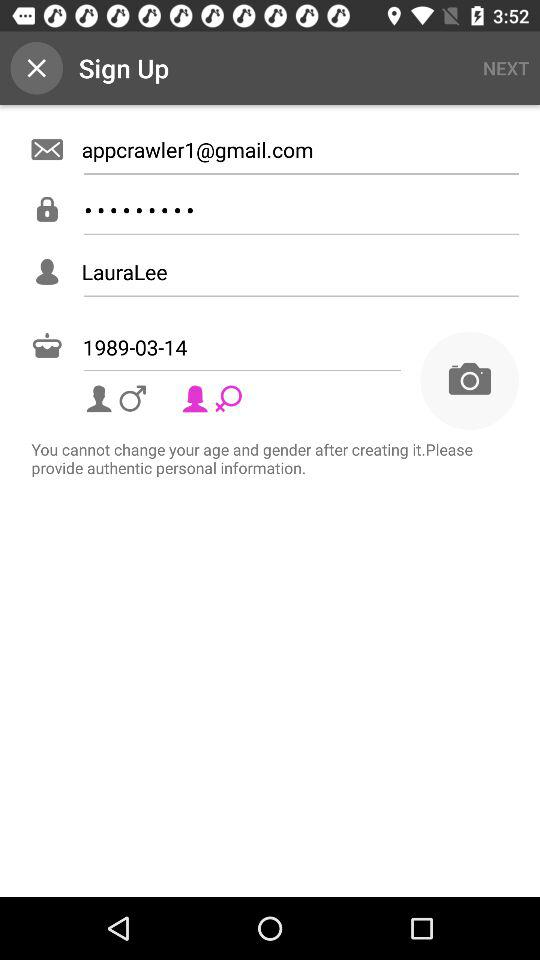How many fields require you to enter text?
Answer the question using a single word or phrase. 4 